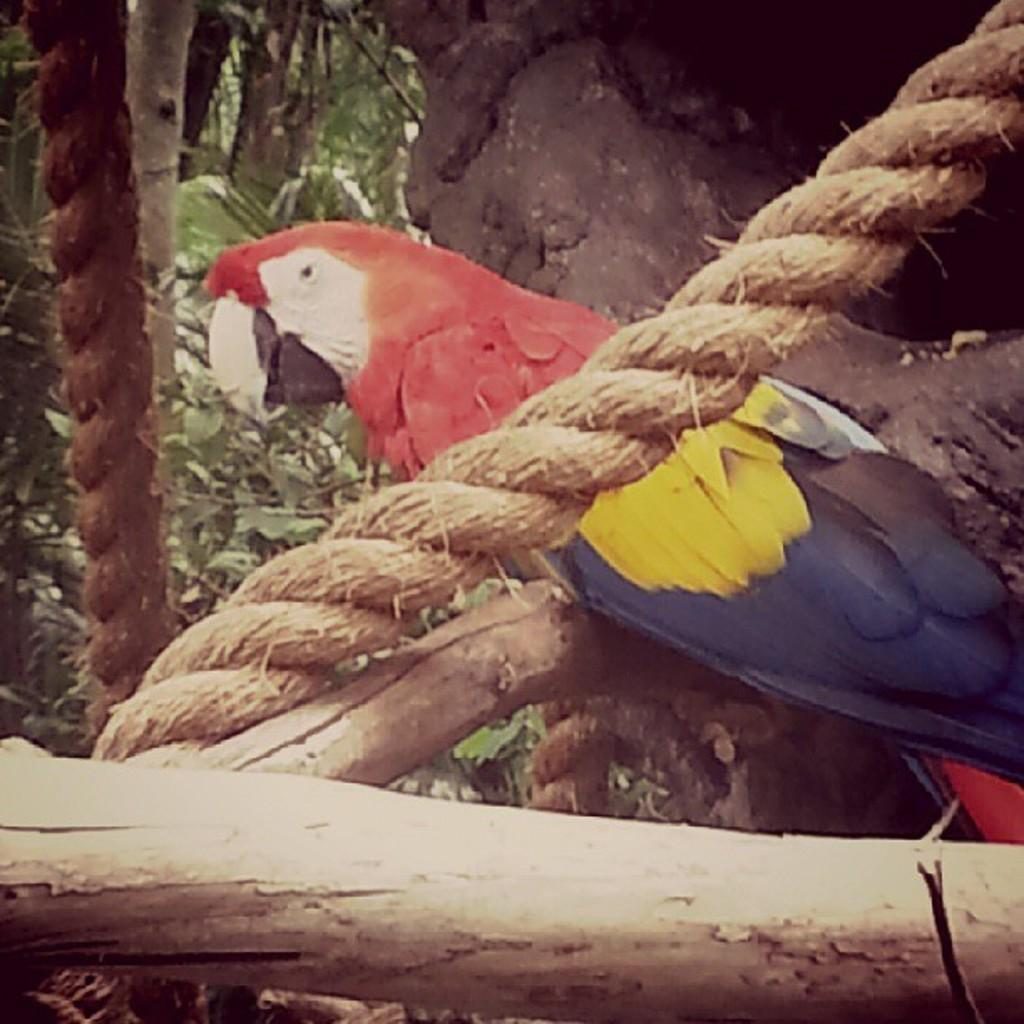What type of animal is in the image? There is a parrot in the image. What other objects can be seen in the image? There are ropes and wooden objects in the image. What can be seen in the background of the image? There are trees in the background of the image. What advice does the parrot give to the wooden objects in the image? There is no indication in the image that the parrot is giving advice to the wooden objects, as the image does not depict any interaction between them. 